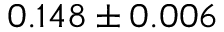Convert formula to latex. <formula><loc_0><loc_0><loc_500><loc_500>0 . 1 4 8 \pm 0 . 0 0 6</formula> 